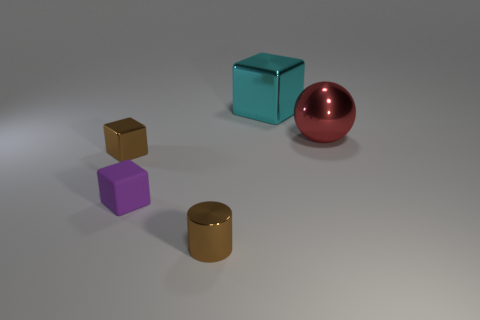There is a small object that is the same color as the metal cylinder; what shape is it?
Offer a very short reply. Cube. Is the large object to the right of the large cyan cube made of the same material as the small brown object behind the cylinder?
Provide a succinct answer. Yes. Is there anything else that has the same shape as the red metal object?
Ensure brevity in your answer.  No. What color is the small rubber cube?
Your answer should be very brief. Purple. What number of other tiny objects are the same shape as the small rubber object?
Your answer should be very brief. 1. There is another metal object that is the same size as the cyan thing; what is its color?
Your answer should be very brief. Red. Are any large red things visible?
Provide a short and direct response. Yes. There is a tiny shiny thing that is left of the tiny metal cylinder; what shape is it?
Your answer should be compact. Cube. What number of metal things are behind the small purple cube and on the right side of the tiny purple object?
Give a very brief answer. 2. Is there a brown block made of the same material as the ball?
Offer a terse response. Yes. 